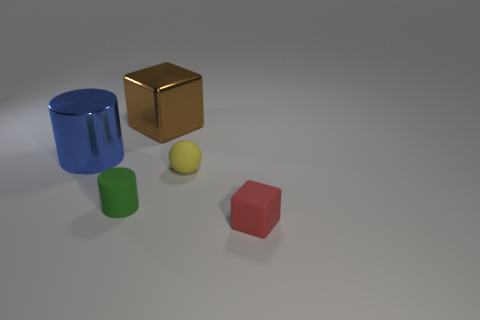There is a thing that is to the right of the rubber thing behind the tiny green matte cylinder; how big is it?
Your response must be concise. Small. How big is the rubber block?
Keep it short and to the point. Small. What shape is the rubber thing that is both in front of the yellow object and to the right of the brown metallic thing?
Make the answer very short. Cube. The other object that is the same shape as the blue metallic thing is what color?
Provide a succinct answer. Green. How many objects are objects that are to the left of the matte ball or rubber objects that are behind the tiny green matte thing?
Provide a succinct answer. 4. The green rubber thing is what shape?
Your answer should be compact. Cylinder. What number of tiny red objects have the same material as the brown block?
Offer a very short reply. 0. What is the color of the large metallic cube?
Your response must be concise. Brown. What color is the rubber block that is the same size as the green rubber cylinder?
Provide a succinct answer. Red. There is a thing that is to the left of the tiny green thing; is it the same shape as the small matte object left of the big brown thing?
Offer a terse response. Yes. 